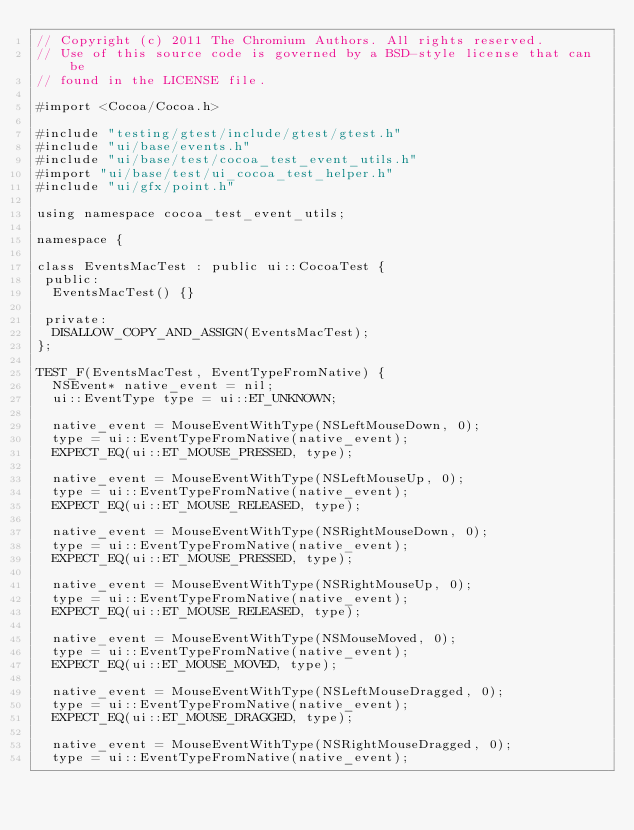<code> <loc_0><loc_0><loc_500><loc_500><_ObjectiveC_>// Copyright (c) 2011 The Chromium Authors. All rights reserved.
// Use of this source code is governed by a BSD-style license that can be
// found in the LICENSE file.

#import <Cocoa/Cocoa.h>

#include "testing/gtest/include/gtest/gtest.h"
#include "ui/base/events.h"
#include "ui/base/test/cocoa_test_event_utils.h"
#import "ui/base/test/ui_cocoa_test_helper.h"
#include "ui/gfx/point.h"

using namespace cocoa_test_event_utils;

namespace {

class EventsMacTest : public ui::CocoaTest {
 public:
  EventsMacTest() {}

 private:
  DISALLOW_COPY_AND_ASSIGN(EventsMacTest);
};

TEST_F(EventsMacTest, EventTypeFromNative) {
  NSEvent* native_event = nil;
  ui::EventType type = ui::ET_UNKNOWN;

  native_event = MouseEventWithType(NSLeftMouseDown, 0);
  type = ui::EventTypeFromNative(native_event);
  EXPECT_EQ(ui::ET_MOUSE_PRESSED, type);

  native_event = MouseEventWithType(NSLeftMouseUp, 0);
  type = ui::EventTypeFromNative(native_event);
  EXPECT_EQ(ui::ET_MOUSE_RELEASED, type);

  native_event = MouseEventWithType(NSRightMouseDown, 0);
  type = ui::EventTypeFromNative(native_event);
  EXPECT_EQ(ui::ET_MOUSE_PRESSED, type);

  native_event = MouseEventWithType(NSRightMouseUp, 0);
  type = ui::EventTypeFromNative(native_event);
  EXPECT_EQ(ui::ET_MOUSE_RELEASED, type);

  native_event = MouseEventWithType(NSMouseMoved, 0);
  type = ui::EventTypeFromNative(native_event);
  EXPECT_EQ(ui::ET_MOUSE_MOVED, type);

  native_event = MouseEventWithType(NSLeftMouseDragged, 0);
  type = ui::EventTypeFromNative(native_event);
  EXPECT_EQ(ui::ET_MOUSE_DRAGGED, type);

  native_event = MouseEventWithType(NSRightMouseDragged, 0);
  type = ui::EventTypeFromNative(native_event);</code> 